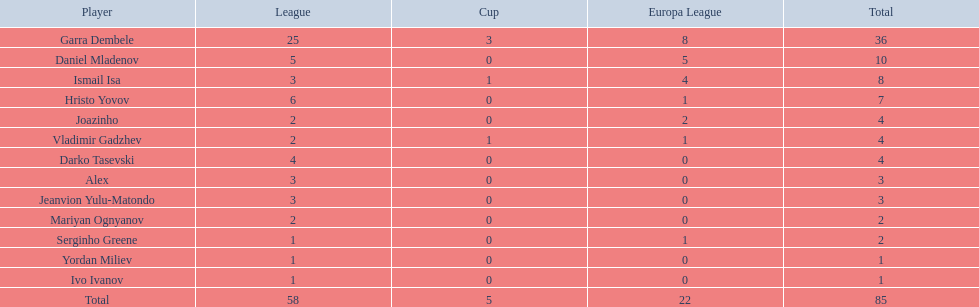Which athletes have a minimum of 4 in the europa league? Garra Dembele, Daniel Mladenov, Ismail Isa. 